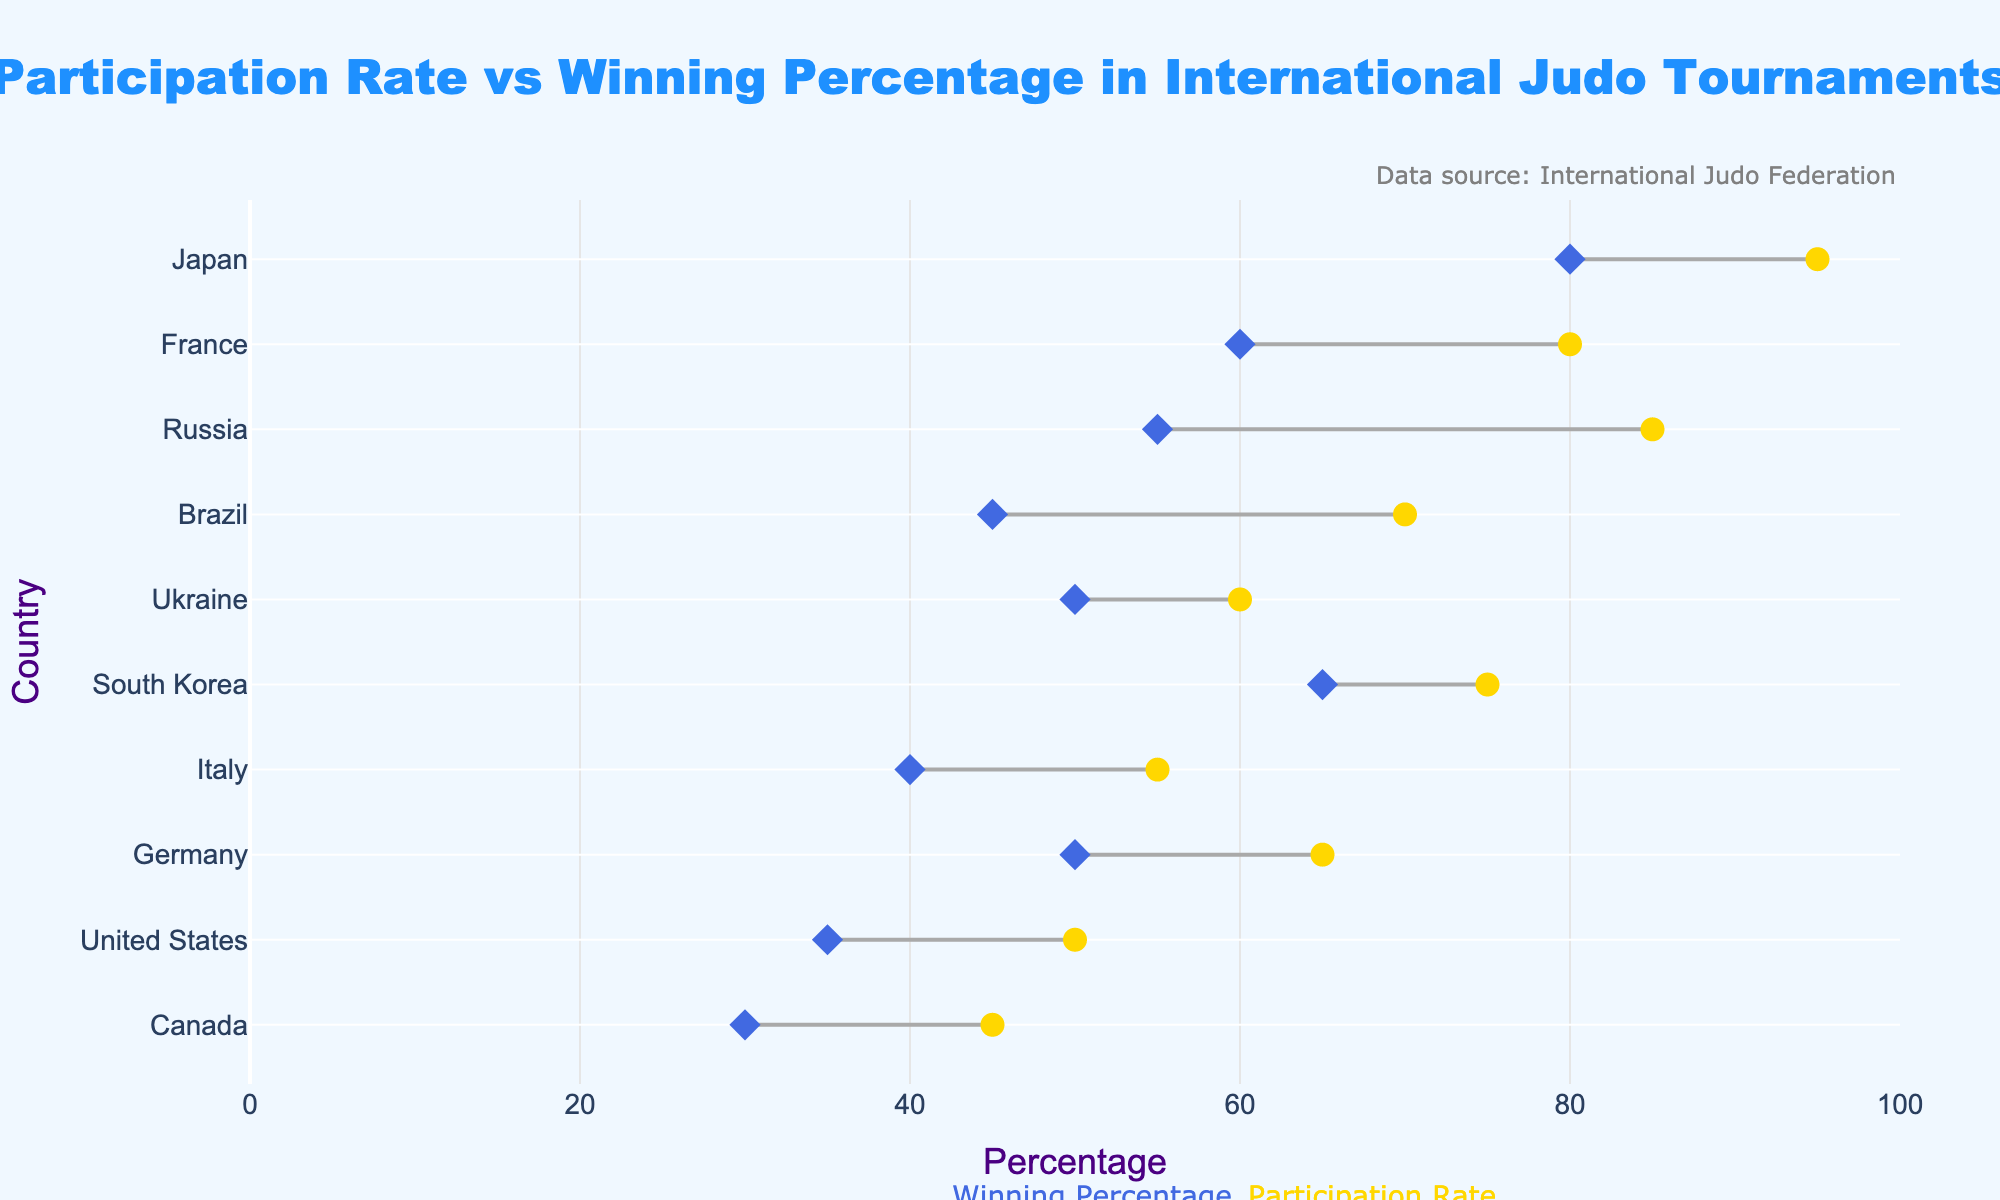What's the title of the plot? The title is prominently displayed at the top of the plot. It reads 'Participation Rate vs Winning Percentage in International Judo Tournaments'.
Answer: Participation Rate vs Winning Percentage in International Judo Tournaments Which country has the highest Participation Rate? The plot shows the Participation Rate on the x-axis and lists the countries on the y-axis. Japan has the highest Participation Rate at 95%.
Answer: Japan What is the average Winning Percentage across all countries? To find the average Winning Percentage, sum all the Winning Percentages and divide by the number of countries. (80 + 60 + 55 + 45 + 50 + 65 + 40 + 50 + 35 + 30) / 10 = 51%.
Answer: 51% How does Ukraine's Winning Percentage compare to its Participation Rate? Ukraine's data point shows a Participation Rate of 60% and a Winning Percentage of 50%. The Winning Percentage is 10 percentage points lower than the Participation Rate.
Answer: 10 percentage points lower What is the range of Participation Rates shown in the plot? The Participation Rates range from the minimum to the maximum values visible on the x-axis. The lowest is 45% (Canada), and the highest is 95% (Japan), so the range is 95% - 45% = 50%.
Answer: 50% Which countries have both Participation Rates and Winning Percentages above 50%? By examining the figure, Japan, France, South Korea, Russia, and Ukraine have both Participation Rates and Winning Percentages above 50%.
Answer: Japan, France, South Korea, Russia, Ukraine Which country has the lowest Winning Percentage? The plot indicates the Winning Percentage for each country. Canada has the lowest Winning Percentage at 30%.
Answer: Canada What is the difference between the Participation Rate and Winning Percentage for South Korea? South Korea has a Participation Rate of 75% and a Winning Percentage of 65%. The difference is 75% - 65% = 10%.
Answer: 10% How many countries have a Winning Percentage below the average? The average Winning Percentage is 51%. The countries with Winning Percentages below this average are Russia (55%), Brazil (45%), Italy (40%), Germany (50%), United States (35%), and Canada (30%). There are 6 such countries.
Answer: 6 